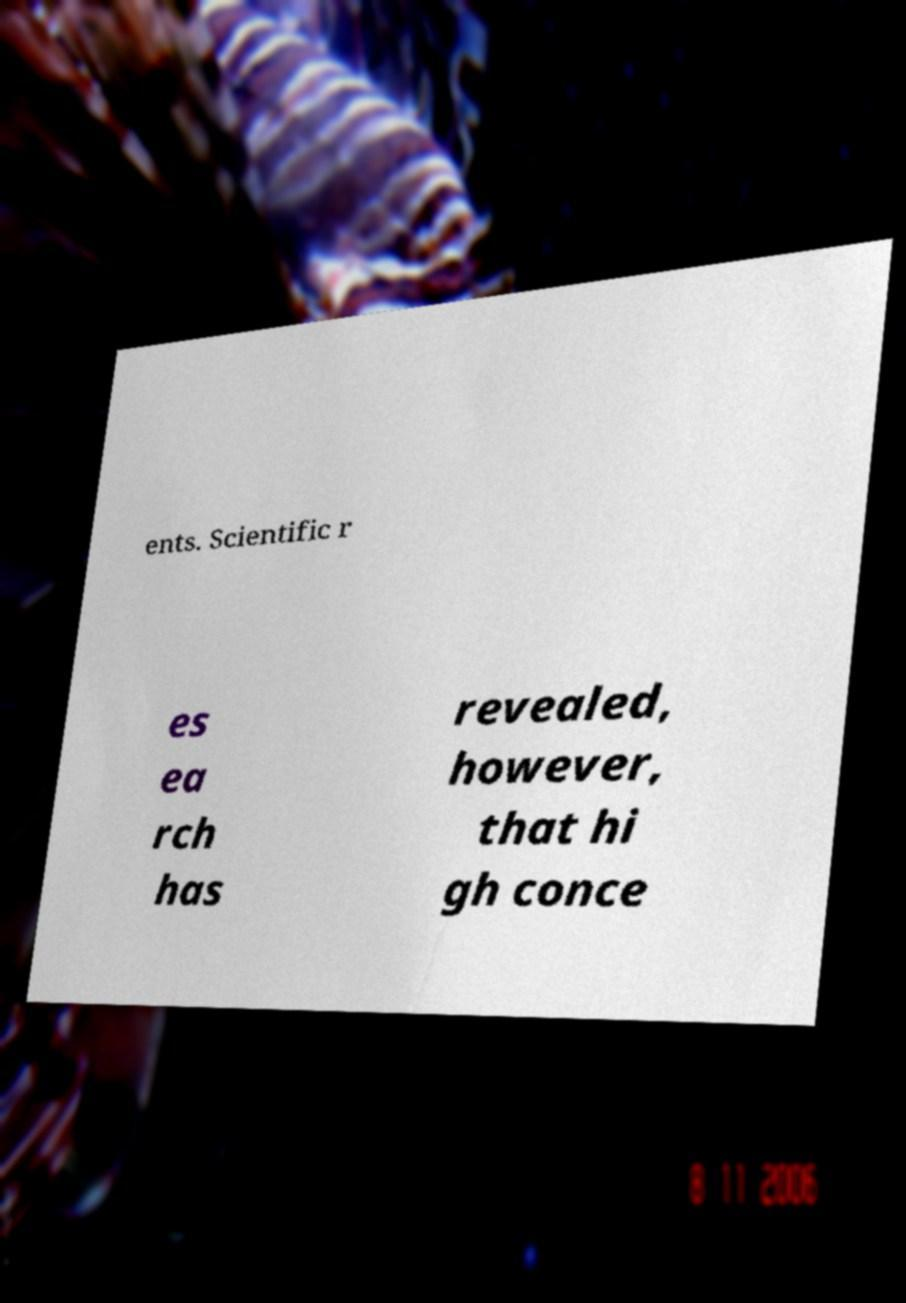Can you read and provide the text displayed in the image?This photo seems to have some interesting text. Can you extract and type it out for me? ents. Scientific r es ea rch has revealed, however, that hi gh conce 